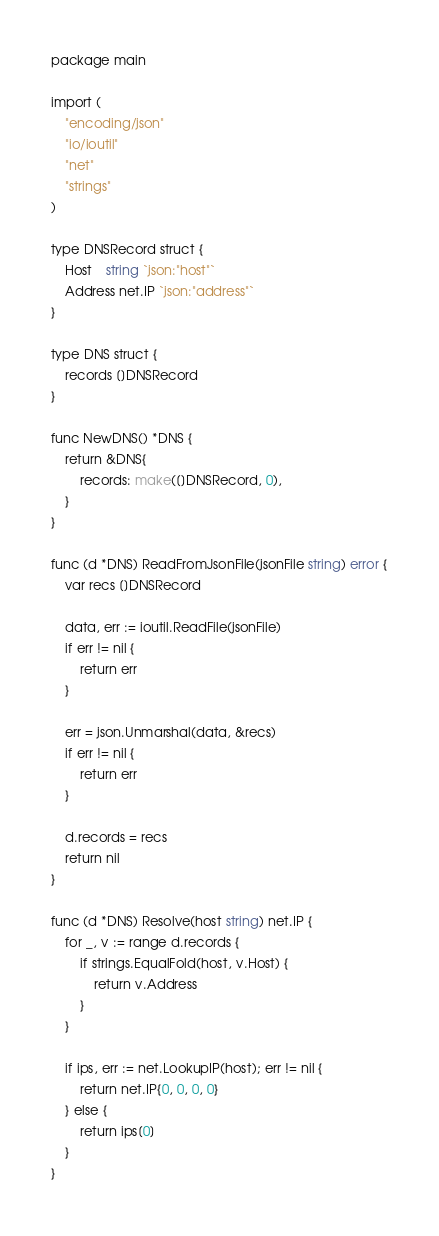Convert code to text. <code><loc_0><loc_0><loc_500><loc_500><_Go_>package main

import (
	"encoding/json"
	"io/ioutil"
	"net"
	"strings"
)

type DNSRecord struct {
	Host    string `json:"host"`
	Address net.IP `json:"address"`
}

type DNS struct {
	records []DNSRecord
}

func NewDNS() *DNS {
	return &DNS{
		records: make([]DNSRecord, 0),
	}
}

func (d *DNS) ReadFromJsonFile(jsonFile string) error {
	var recs []DNSRecord

	data, err := ioutil.ReadFile(jsonFile)
	if err != nil {
		return err
	}

	err = json.Unmarshal(data, &recs)
	if err != nil {
		return err
	}

	d.records = recs
	return nil
}

func (d *DNS) Resolve(host string) net.IP {
	for _, v := range d.records {
		if strings.EqualFold(host, v.Host) {
			return v.Address
		}
	}

	if ips, err := net.LookupIP(host); err != nil {
		return net.IP{0, 0, 0, 0}
	} else {
		return ips[0]
	}
}
</code> 